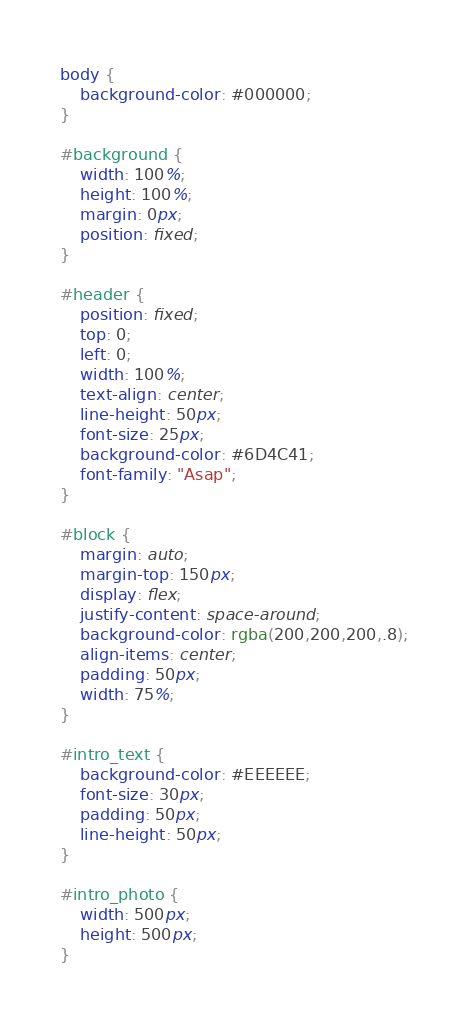Convert code to text. <code><loc_0><loc_0><loc_500><loc_500><_CSS_>body {
	background-color: #000000;
}

#background {
	width: 100%;
	height: 100%;
	margin: 0px;
	position: fixed;
}

#header {
	position: fixed;
	top: 0;
	left: 0;
	width: 100%;
	text-align: center;
	line-height: 50px;
	font-size: 25px;
	background-color: #6D4C41;
	font-family: "Asap";
}

#block {
	margin: auto;
	margin-top: 150px;
	display: flex;
	justify-content: space-around;
	background-color: rgba(200,200,200,.8);
	align-items: center;
	padding: 50px;
	width: 75%;
}

#intro_text {
	background-color: #EEEEEE;
	font-size: 30px;
	padding: 50px;
	line-height: 50px;
}

#intro_photo {
	width: 500px;
	height: 500px;
}</code> 